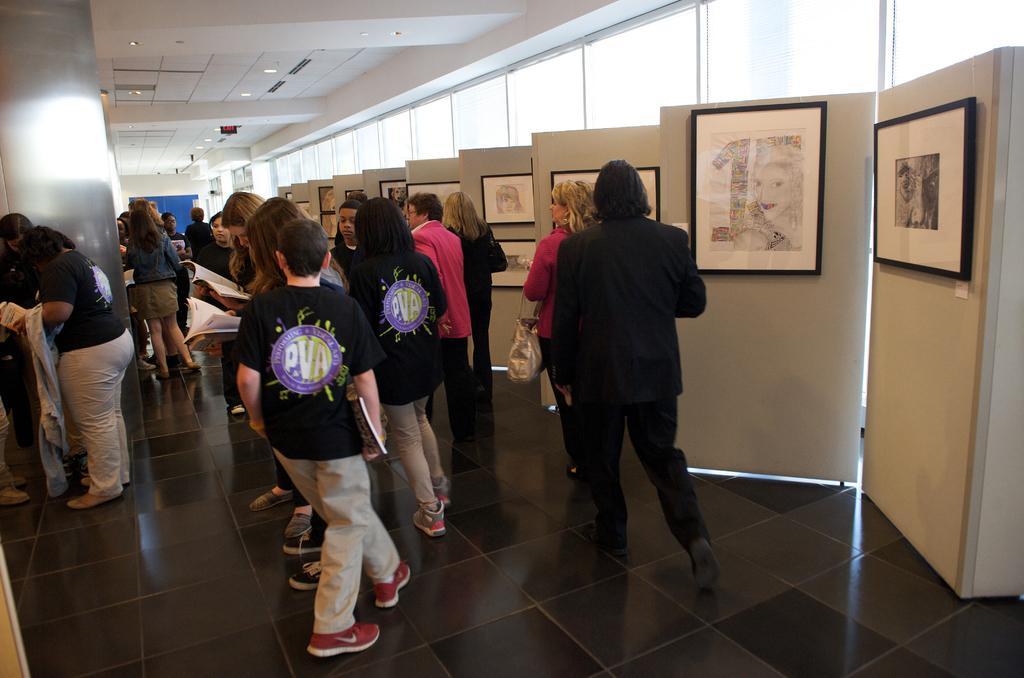Describe this image in one or two sentences. In this image we can see persons walking and standing on the floor and some of them are holding books in their hands. In the background we can see windows, wall hangings attached to the walls and electric lights. 